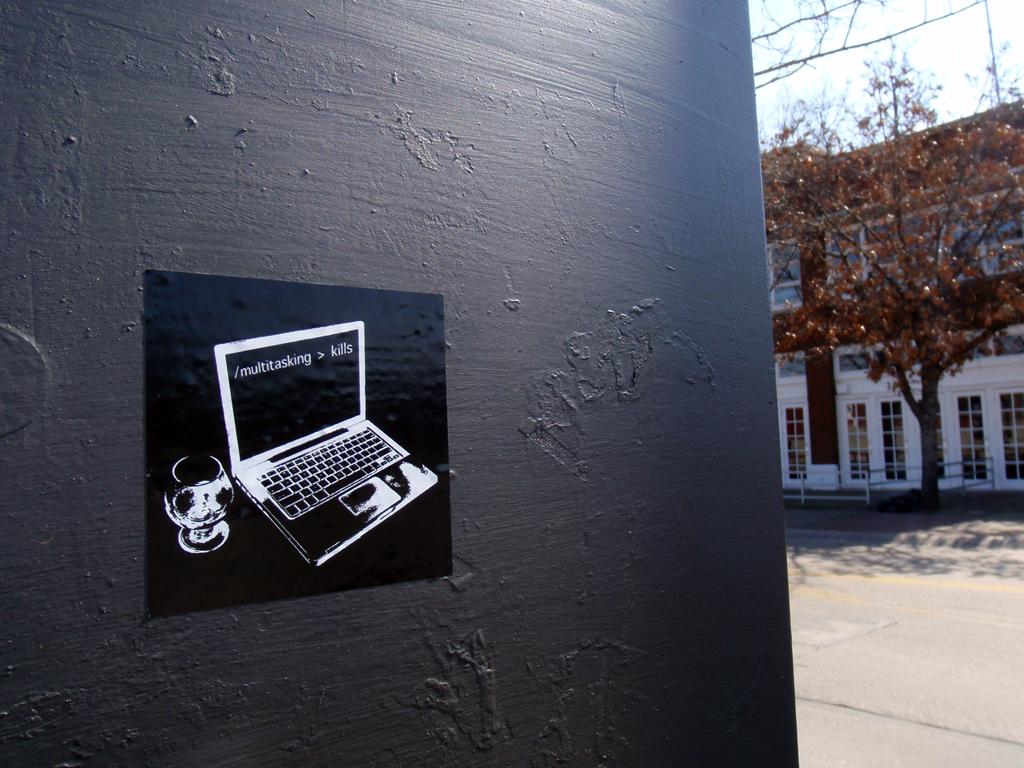What is written on the screen on the poster?
Offer a terse response. /multitasking > kills. 